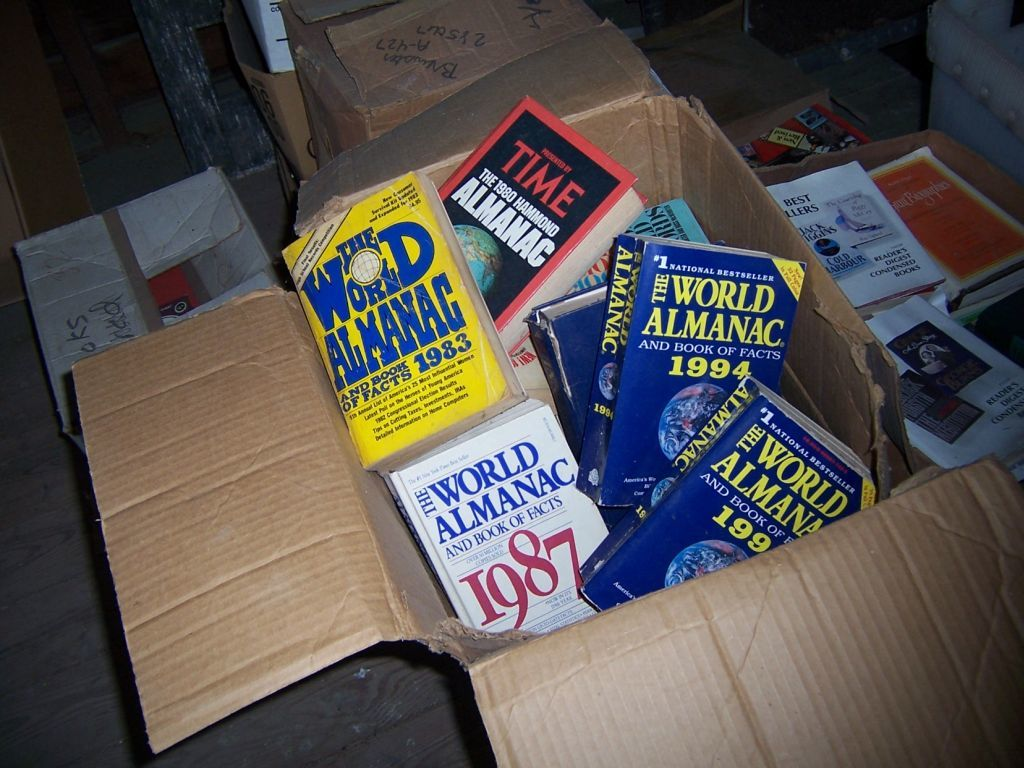Provide a one-sentence caption for the provided image.
Reference OCR token: LOOINE!, WOD, ILMANRE, TIME, ALMANAG, ANDB, NATIONA, REL, WORLD, 1983, ALMANAC, PRADRIRT, WORLD, CHE, IYMANA, FACTS, LMAN, 19, WORLD, Femonat, ANDBOOK, 1987 World amanac books inside of a cardboard box. 